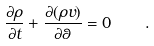<formula> <loc_0><loc_0><loc_500><loc_500>\frac { \partial \rho } { \partial t } + \frac { \partial ( \rho v ) } { \partial \theta } = 0 \quad .</formula> 